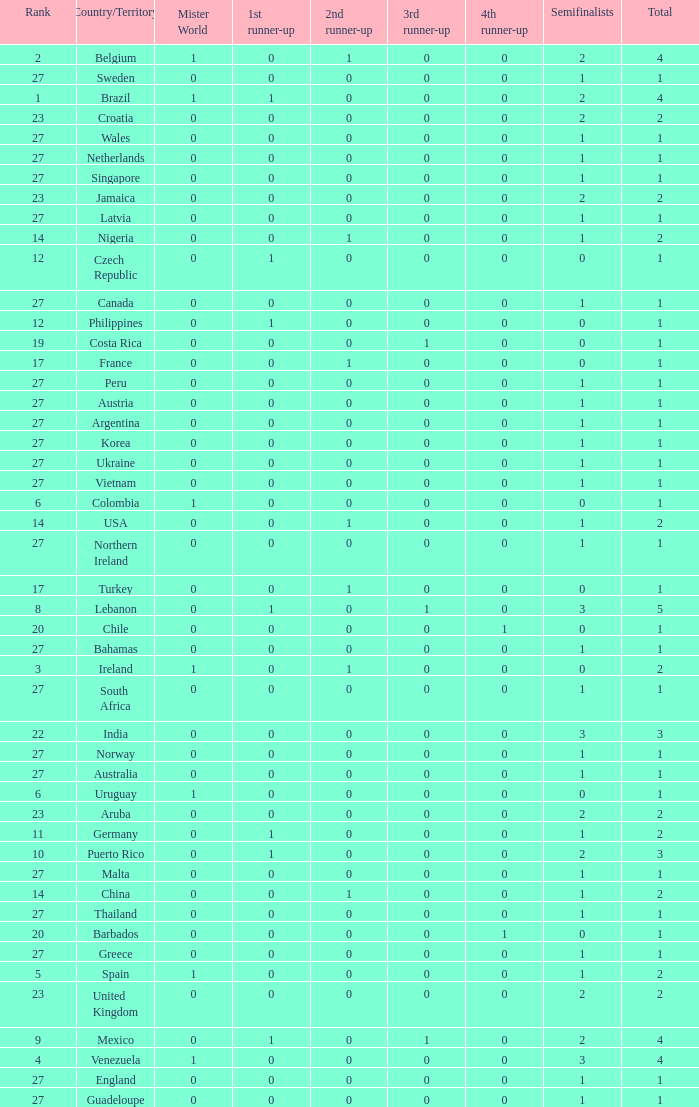How many 3rd runner up values does Turkey have? 1.0. 